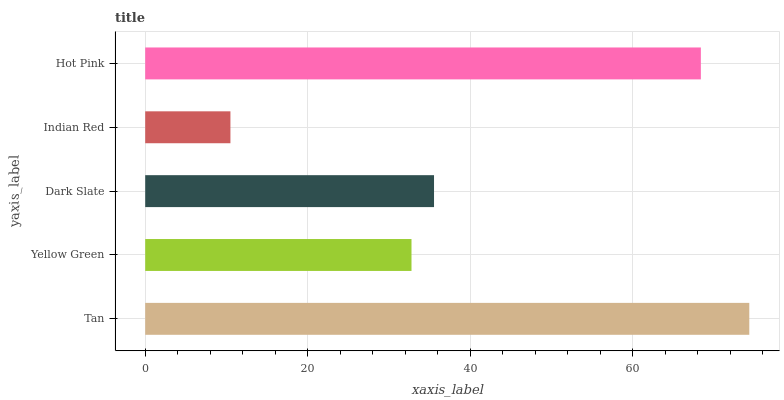Is Indian Red the minimum?
Answer yes or no. Yes. Is Tan the maximum?
Answer yes or no. Yes. Is Yellow Green the minimum?
Answer yes or no. No. Is Yellow Green the maximum?
Answer yes or no. No. Is Tan greater than Yellow Green?
Answer yes or no. Yes. Is Yellow Green less than Tan?
Answer yes or no. Yes. Is Yellow Green greater than Tan?
Answer yes or no. No. Is Tan less than Yellow Green?
Answer yes or no. No. Is Dark Slate the high median?
Answer yes or no. Yes. Is Dark Slate the low median?
Answer yes or no. Yes. Is Hot Pink the high median?
Answer yes or no. No. Is Indian Red the low median?
Answer yes or no. No. 